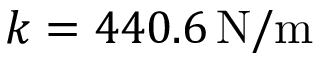<formula> <loc_0><loc_0><loc_500><loc_500>k = 4 4 0 . 6 \, N / m</formula> 